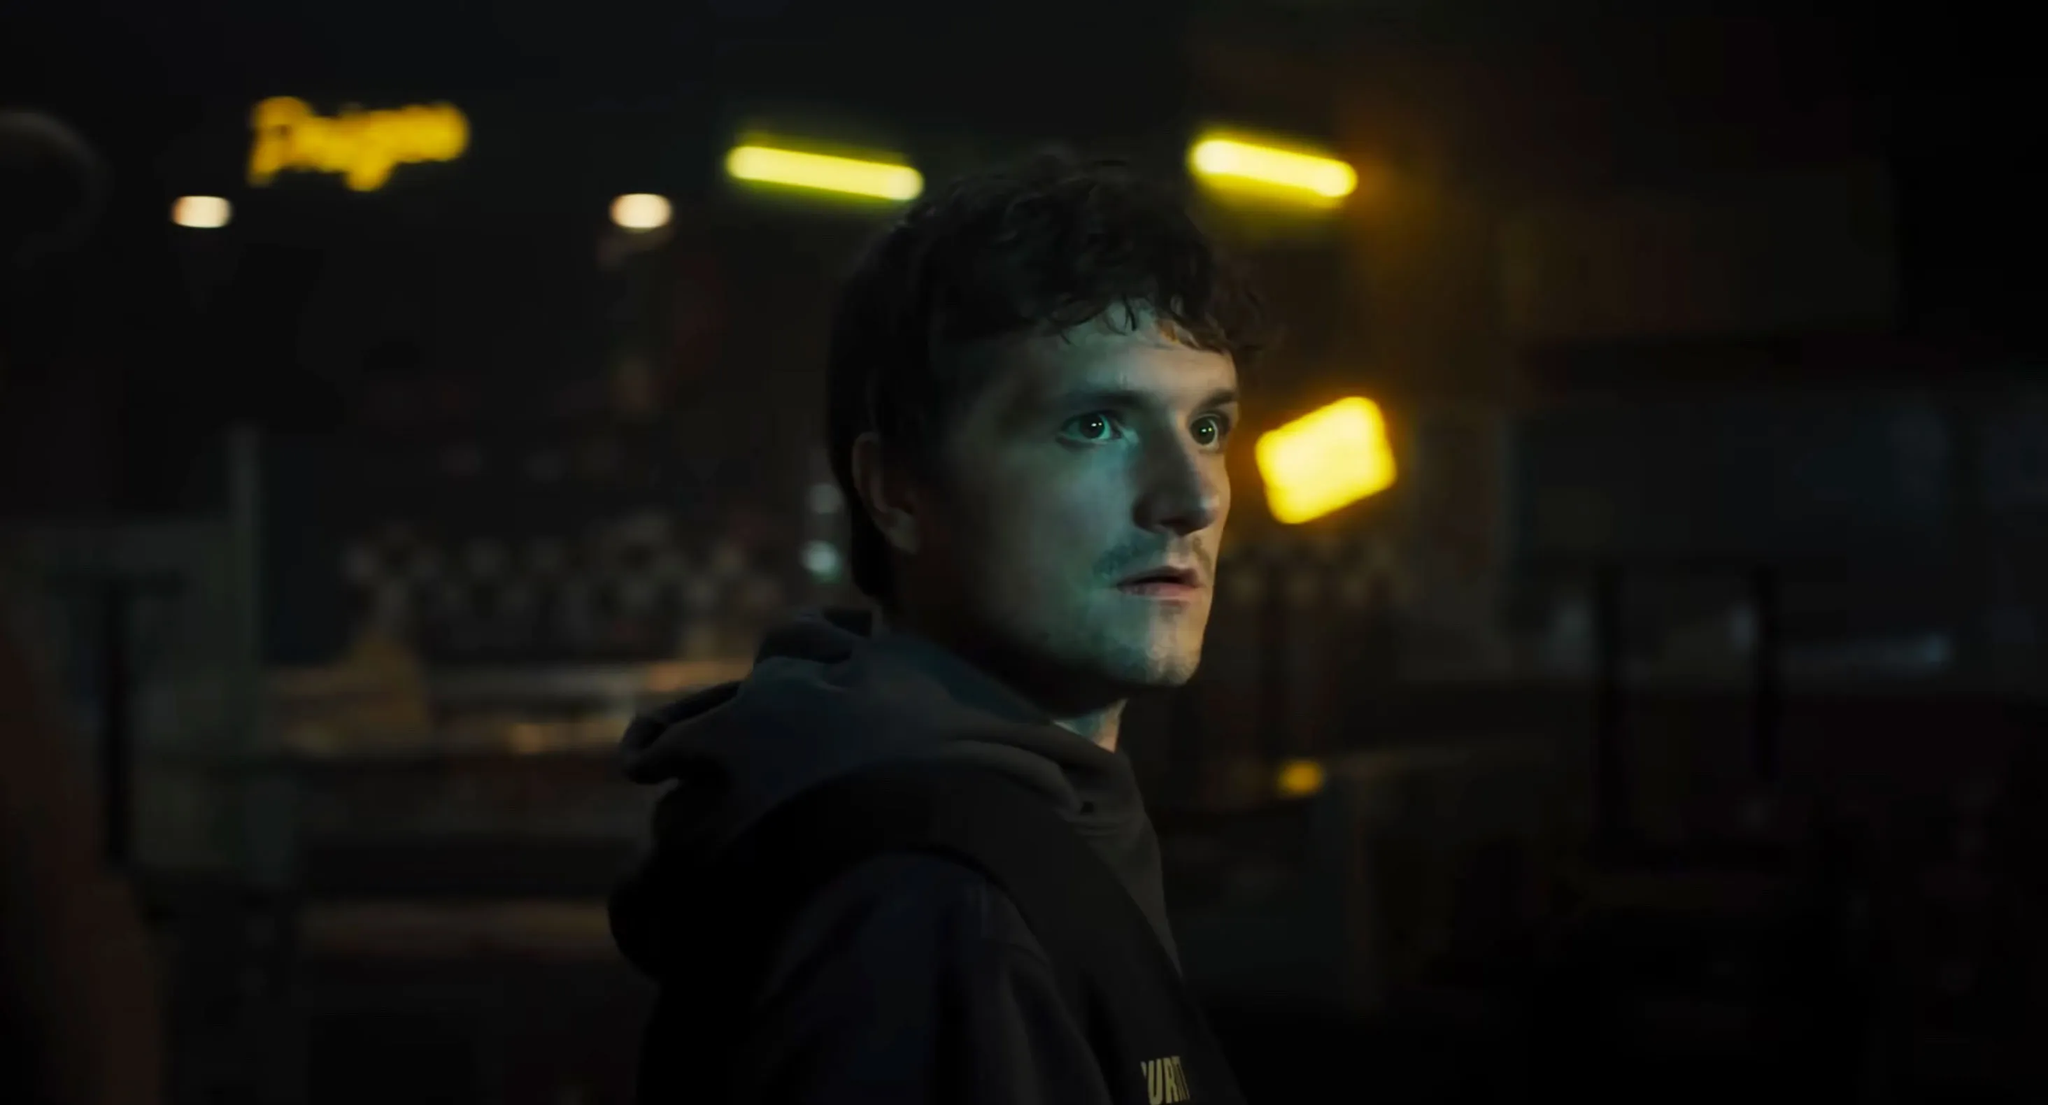Write a detailed description of the given image. In the image, a man is centrally framed in a dimly lit room, evoking a sense of quiet intensity. The soft yellow lights in the background provide a subdued, yet captivating ambiance. The man is dressed in a black hoodie which stands out against the dark and moody backdrop. His gaze is directed off to the side, suggesting deep contemplation. The room itself has a checkerboard pattern and a slightly blurred neon sign, adding an element of mystery and intrigue. His serious expression further enhances the overall enigmatic atmosphere of the scene. 